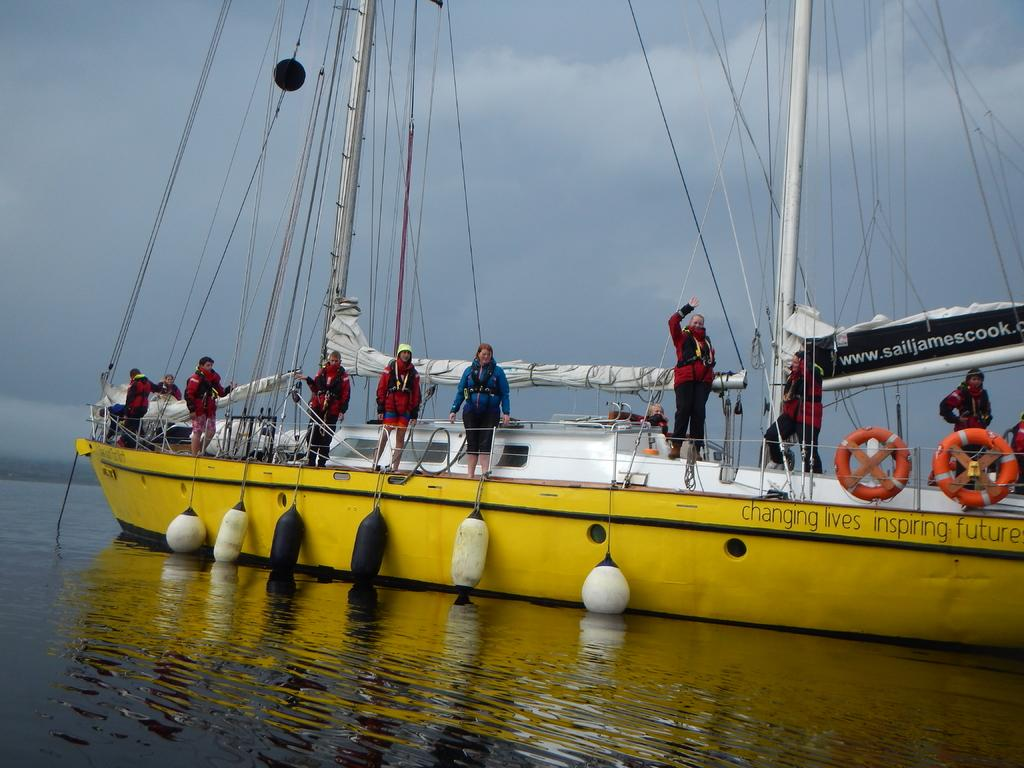What is the main subject of the image? The main subject of the image is a boat. What is the boat doing in the image? The boat is sailing on the surface of the water. Are there any additional items or objects associated with the boat? Yes, there are bags hanging from the boat. Are there any people on the boat? Yes, there are people standing on the boat. What is visible at the top of the image? The sky is visible at the top of the image. Can you tell me how many receipts are floating in the water near the boat? There are no receipts visible in the image; it only features a boat sailing on the water with bags hanging from it and people standing on it. What type of star can be seen shining brightly in the sky above the boat? There is no star visible in the sky above the boat in the image. 